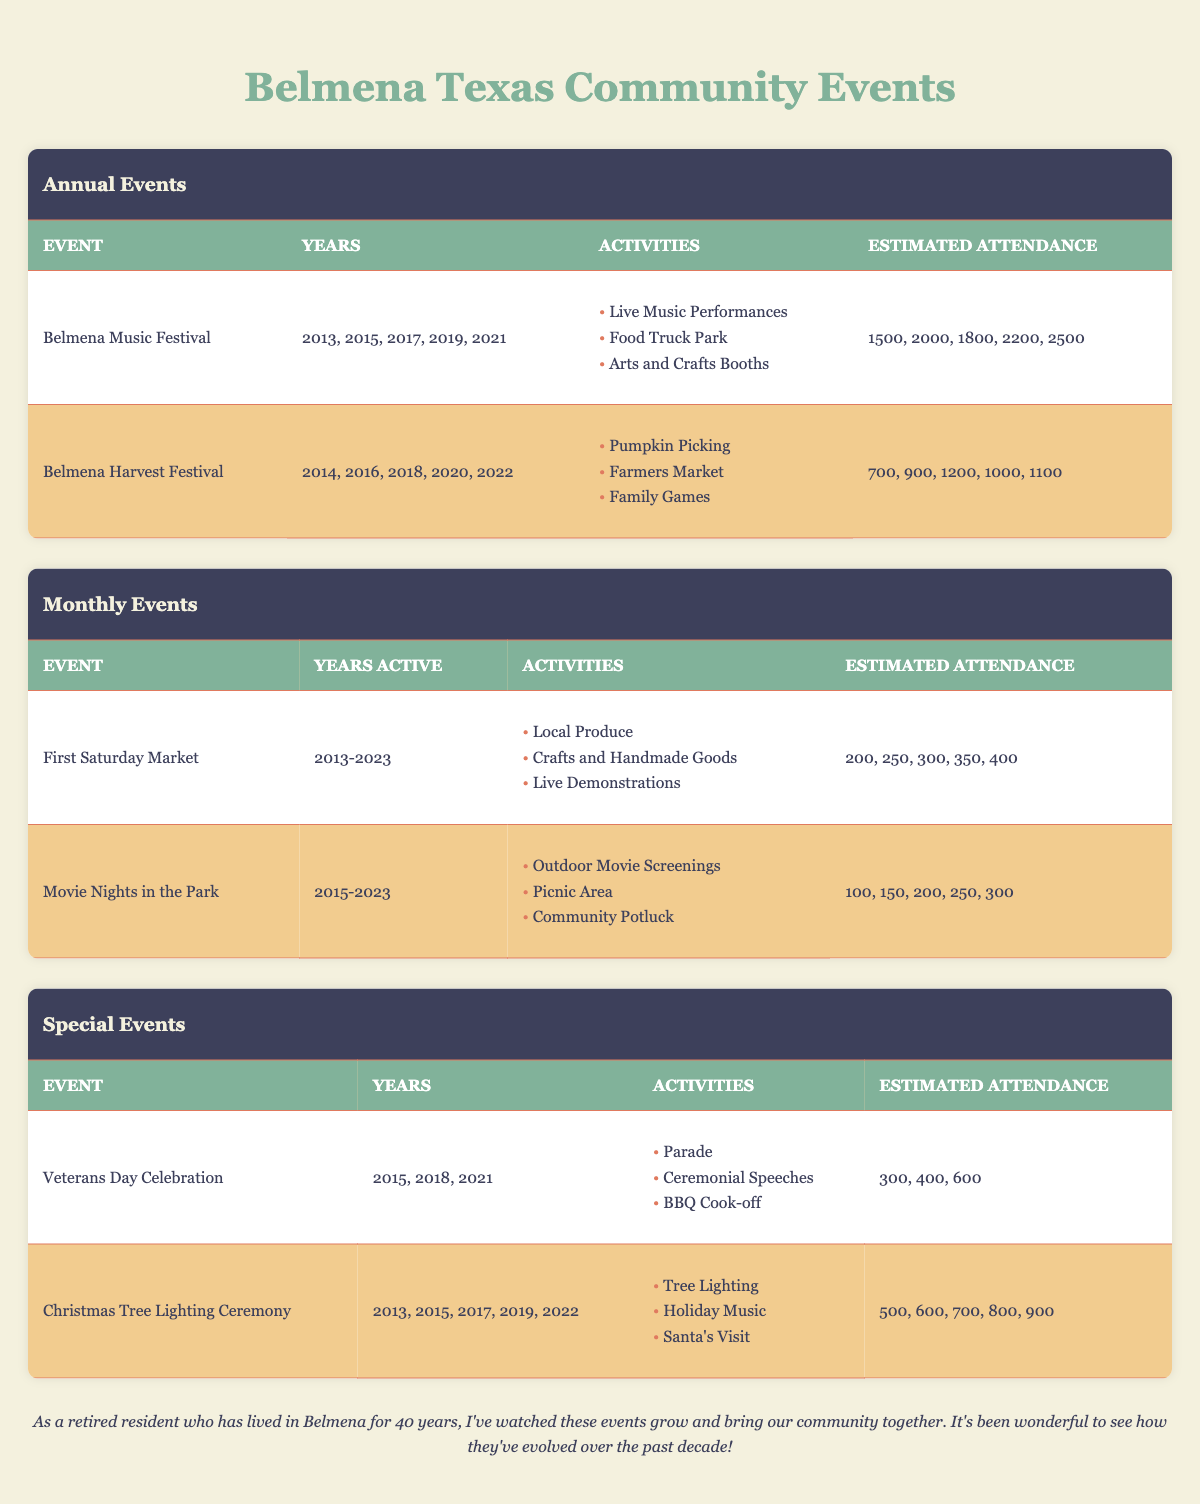What years did the Belmena Music Festival occur? The Belmena Music Festival took place in the years 2013, 2015, 2017, 2019, and 2021 as listed in the table under the event's details.
Answer: 2013, 2015, 2017, 2019, 2021 What is the total estimated attendance for the Belmena Harvest Festival over its five occurrences? To find the total estimated attendance, add the individual attendance numbers: 700 + 900 + 1200 + 1000 + 1100 = 3900.
Answer: 3900 Did the First Saturday Market have an attendance of over 300 in any year? By reviewing the estimated attendance numbers for the First Saturday Market, it shows 200, 250, 300, 350, and 400. The year with 350 and 400 indicates it did exceed 300.
Answer: Yes What was the highest estimated attendance for an annual event, and which event was it? The highest estimated attendance recorded among annual events is 2500 at the Belmena Music Festival in 2021, as seen in the attendance data.
Answer: 2500 for Belmena Music Festival Which special event had a higher estimated attendance in 2021: the Veterans Day Celebration or the Christmas Tree Lighting Ceremony? In 2021, the Veterans Day Celebration had an attendance of 600, while the Christmas Tree Lighting Ceremony had an attendance of 900. Therefore, the Christmas Tree Lighting Ceremony had a higher attendance that year.
Answer: Christmas Tree Lighting Ceremony What is the average estimated attendance for the Movie Nights in the Park? The estimated attendances for the Movie Nights in the Park are 100, 150, 200, 250, and 300. The total attendance is 100 + 150 + 200 + 250 + 300 = 1000. Dividing this by 5 gives an average of 1000/5 = 200.
Answer: 200 Which event had the lowest estimated attendance in its most recent occurrence? The most recent attendance numbers for each event indicate the Belmena Harvest Festival had an attendance of 1100 in 2022, while the Veterans Day Celebration had 600 in 2021. Thus, the Veterans Day Celebration had the lowest most recent attendance.
Answer: Veterans Day Celebration 